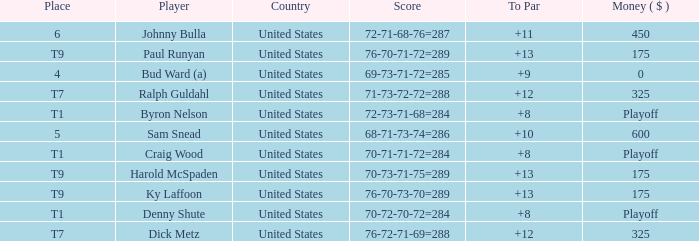What was the total To Par for Craig Wood? 8.0. 